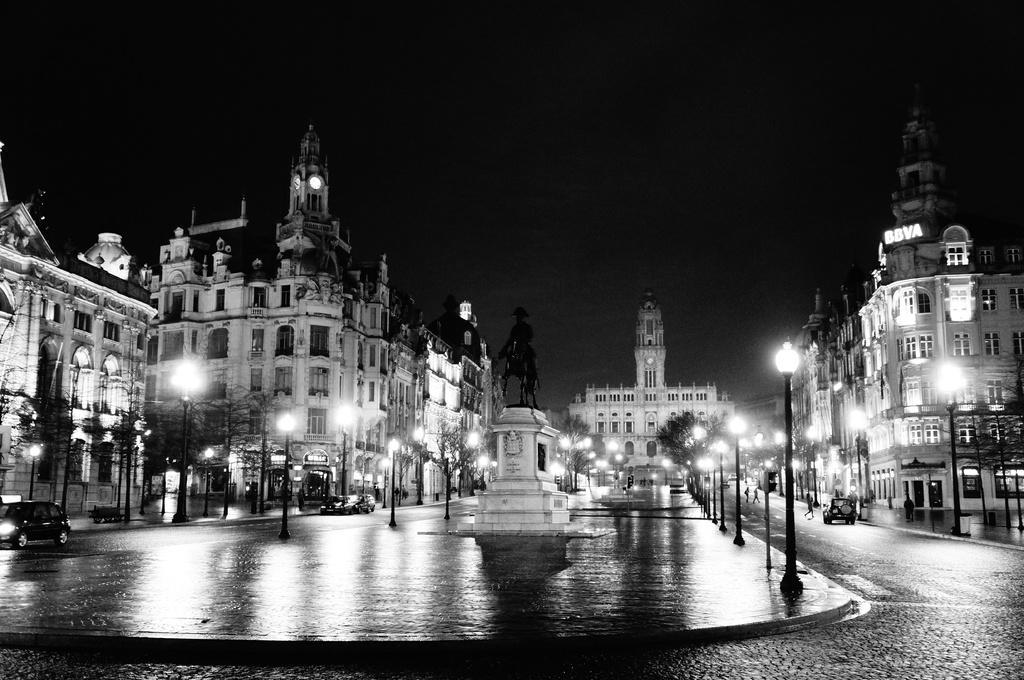Could you give a brief overview of what you see in this image? This is the picture of a city. In this image there are buildings and trees and there are poles. In the middle of the image there is a statue and there are vehicles on the road and there are group of people walking on the road. At the top there is sky. At the bottom there is a road. 